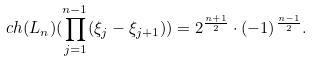<formula> <loc_0><loc_0><loc_500><loc_500>c h ( L _ { n } ) ( \prod _ { j = 1 } ^ { n - 1 } ( \xi _ { j } - \xi _ { j + 1 } ) ) = 2 ^ { \frac { n + 1 } { 2 } } \cdot ( - 1 ) ^ { \frac { n - 1 } { 2 } } .</formula> 